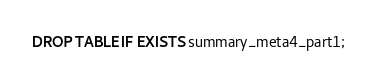Convert code to text. <code><loc_0><loc_0><loc_500><loc_500><_SQL_>DROP TABLE IF EXISTS summary_meta4_part1;</code> 